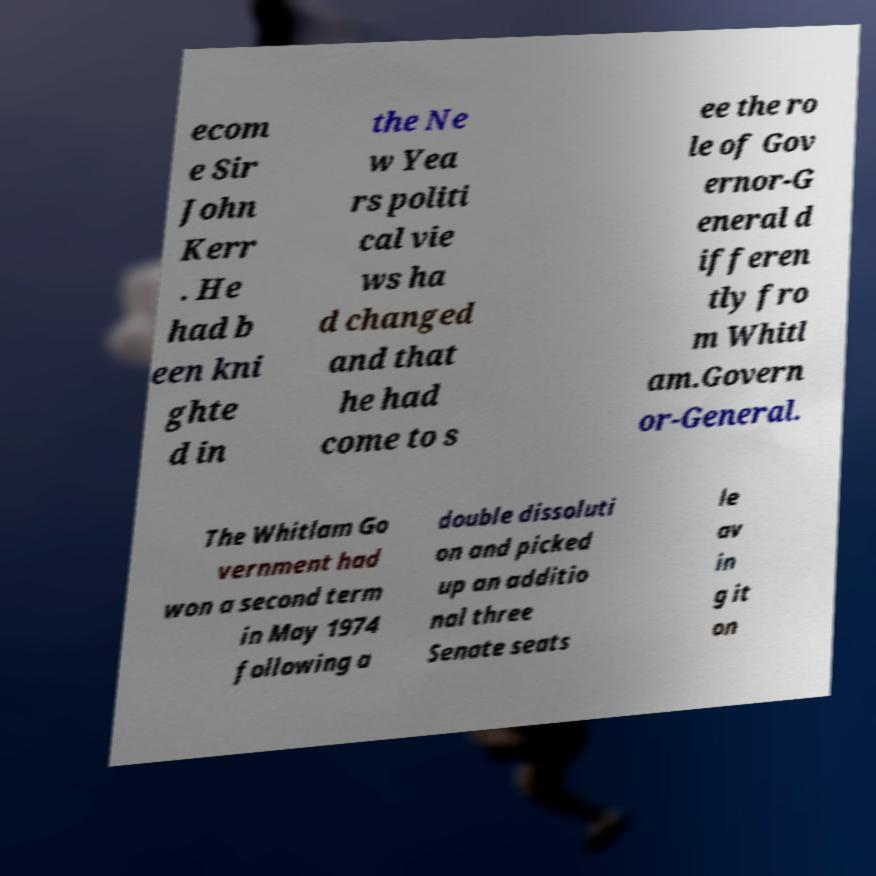There's text embedded in this image that I need extracted. Can you transcribe it verbatim? ecom e Sir John Kerr . He had b een kni ghte d in the Ne w Yea rs politi cal vie ws ha d changed and that he had come to s ee the ro le of Gov ernor-G eneral d ifferen tly fro m Whitl am.Govern or-General. The Whitlam Go vernment had won a second term in May 1974 following a double dissoluti on and picked up an additio nal three Senate seats le av in g it on 